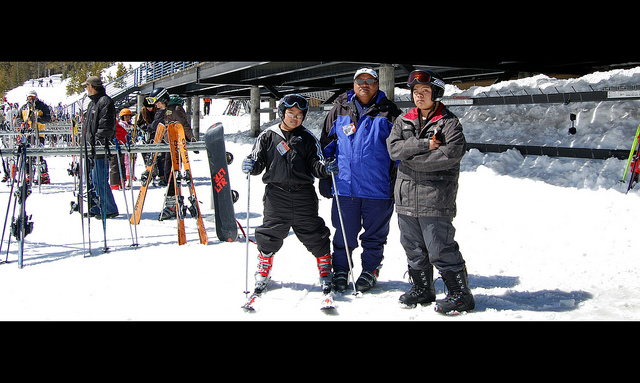Describe the ski gear seen in the image. The ski gear visible in the image includes a pair of skis and ski poles held by the person on the left. He is also wearing ski boots, which are necessary for attaching the skis securely. Additionally, they're all dressed in warm, insulated jackets suitable for the cold ski environment. 